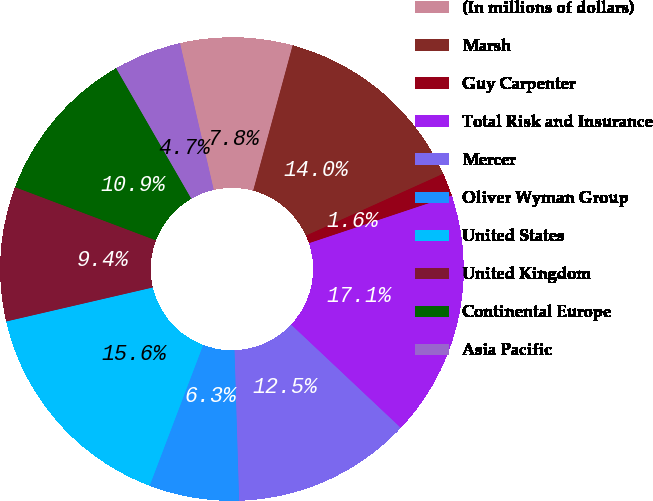Convert chart. <chart><loc_0><loc_0><loc_500><loc_500><pie_chart><fcel>(In millions of dollars)<fcel>Marsh<fcel>Guy Carpenter<fcel>Total Risk and Insurance<fcel>Mercer<fcel>Oliver Wyman Group<fcel>United States<fcel>United Kingdom<fcel>Continental Europe<fcel>Asia Pacific<nl><fcel>7.82%<fcel>14.04%<fcel>1.61%<fcel>17.15%<fcel>12.49%<fcel>6.27%<fcel>15.59%<fcel>9.38%<fcel>10.93%<fcel>4.72%<nl></chart> 